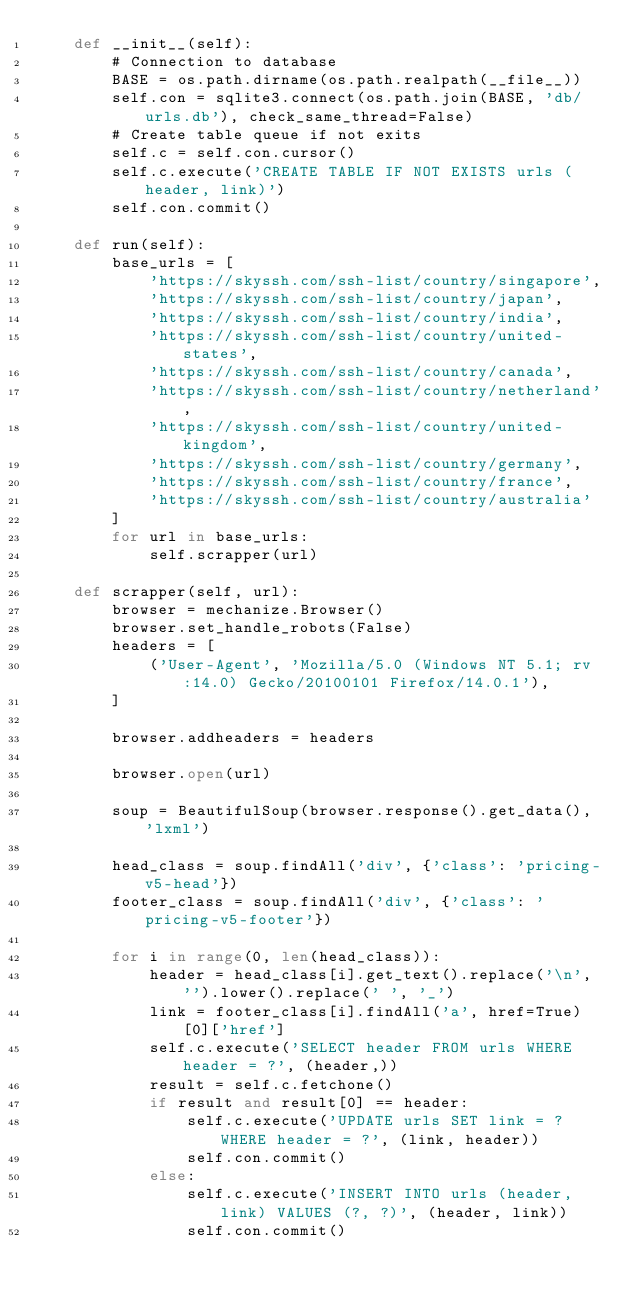<code> <loc_0><loc_0><loc_500><loc_500><_Python_>    def __init__(self):
        # Connection to database
        BASE = os.path.dirname(os.path.realpath(__file__))
        self.con = sqlite3.connect(os.path.join(BASE, 'db/urls.db'), check_same_thread=False)
        # Create table queue if not exits
        self.c = self.con.cursor()
        self.c.execute('CREATE TABLE IF NOT EXISTS urls (header, link)')
        self.con.commit()

    def run(self):
        base_urls = [
            'https://skyssh.com/ssh-list/country/singapore',
            'https://skyssh.com/ssh-list/country/japan',
            'https://skyssh.com/ssh-list/country/india',
            'https://skyssh.com/ssh-list/country/united-states',
            'https://skyssh.com/ssh-list/country/canada',
            'https://skyssh.com/ssh-list/country/netherland',
            'https://skyssh.com/ssh-list/country/united-kingdom',
            'https://skyssh.com/ssh-list/country/germany',
            'https://skyssh.com/ssh-list/country/france',
            'https://skyssh.com/ssh-list/country/australia'
        ]
        for url in base_urls:
            self.scrapper(url)

    def scrapper(self, url):
        browser = mechanize.Browser()
        browser.set_handle_robots(False)
        headers = [
            ('User-Agent', 'Mozilla/5.0 (Windows NT 5.1; rv:14.0) Gecko/20100101 Firefox/14.0.1'),
        ]

        browser.addheaders = headers

        browser.open(url)

        soup = BeautifulSoup(browser.response().get_data(), 'lxml')

        head_class = soup.findAll('div', {'class': 'pricing-v5-head'})
        footer_class = soup.findAll('div', {'class': 'pricing-v5-footer'})

        for i in range(0, len(head_class)):
            header = head_class[i].get_text().replace('\n', '').lower().replace(' ', '_')
            link = footer_class[i].findAll('a', href=True)[0]['href']
            self.c.execute('SELECT header FROM urls WHERE header = ?', (header,))
            result = self.c.fetchone()
            if result and result[0] == header:
                self.c.execute('UPDATE urls SET link = ? WHERE header = ?', (link, header))
                self.con.commit()
            else:
                self.c.execute('INSERT INTO urls (header, link) VALUES (?, ?)', (header, link))
                self.con.commit()
</code> 